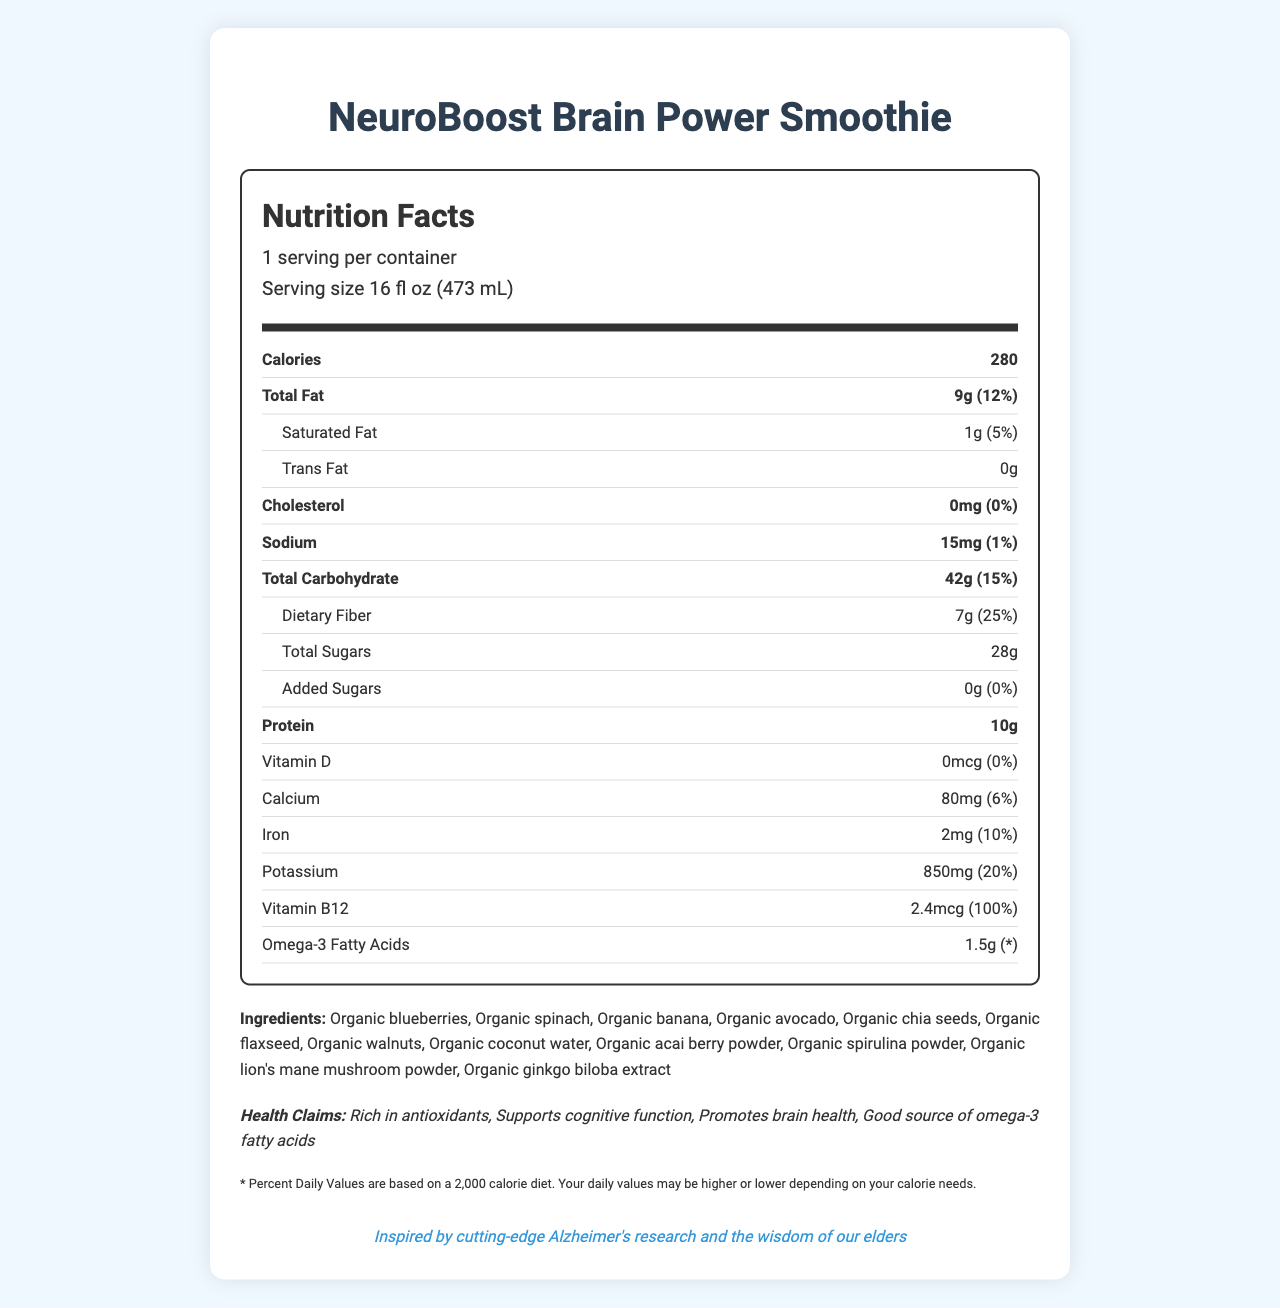what is the serving size? The serving size is stated as "16 fl oz (473 mL)" in the document.
Answer: 16 fl oz (473 mL) how many calories are in one serving? The number of calories per serving is indicated as "280" in the document.
Answer: 280 what is the total amount of dietary fiber per serving? The amount of dietary fiber per serving is given as "7g" in the document.
Answer: 7g what percentage of the daily value is the total fat per serving? The total fat percentage of the daily value per serving is listed as "12%" in the document.
Answer: 12% what is the main health claim of the product? Among the listed health claims, "Supports cognitive function" stands out as a primary claim related to brain health.
Answer: Supports cognitive function which ingredient is an allergen? A. Organic chia seeds B. Organic walnuts C. Organic avocado D. Organic spinach The allergen information indicates that the product contains tree nuts, specifically "walnuts."
Answer: B how much protein does one serving contain? The amount of protein per serving is "10g" as stated in the document.
Answer: 10g does this product contain any trans fat? The document specifies "Trans Fat 0g," indicating there is no trans fat in the product.
Answer: No what is the manufacturer location of the product? The manufacturer is "BrainFuel Nutrition Labs, Los Angeles, CA 90001" as noted in the document.
Answer: Los Angeles, CA 90001 what percentage of the daily value of vitamin B12 is in the smoothie? The document indicates that vitamin B12 is present at 2.4mcg, which is 100% of the daily value.
Answer: 100% if one were to consume two servings, how much vitamin D would they intake? The document states that the amount of vitamin D per serving is "0mcg," so consuming two servings would still result in "0mcg" intake.
Answer: 0mcg which claim is not listed in the health claims section? A. Rich in antioxidants B. Supports cognitive function C. Boosts immunity D. Promotes brain health The health claims listed are "Rich in antioxidants," "Supports cognitive function," and "Promotes brain health." "Boosts immunity" is not mentioned.
Answer: C how much added sugars does the product contain per serving? The document mentions that the added sugars per serving amount to "0g."
Answer: 0g is this product suitable for people with walnut allergies? The allergen information clearly states that the product contains tree nuts (walnuts), making it unsuitable for someone with a walnut allergy.
Answer: No summarize the main idea of the document The document serves to provide detailed nutritional information and emphasize the cognitive and brain health benefits of the NeuroBoost Brain Power Smoothie, listing its features, ingredients, and manufacturer information.
Answer: The NeuroBoost Brain Power Smoothie is a nutrient-packed beverage designed to promote brain health, with key ingredients and vitamins that support cognitive function and rich in antioxidants. The product provides detailed nutritional information, including calories, fats, proteins, carbohydrates, and essential vitamins. It emphasizes brain-boosting ingredients and provides allergen information, health claims, and storage guidelines. how many different organic ingredients are listed? The document lists the following organic ingredients: "Organic blueberries, Organic spinach, Organic banana, Organic avocado, Organic chia seeds, Organic flaxseed, Organic walnuts, Organic coconut water, Organic acai berry powder, Organic spirulina powder, Organic lion's mane mushroom powder, Organic ginkgo biloba extract," totaling 12.
Answer: 12 what are the total sugars per serving, and how do they compare to the added sugars in the document? The document differentiates between "Total Sugars 28g" and "Added Sugars 0g," indicating that all sugars come from natural sources within the ingredients.
Answer: 28g total sugars, 0g added sugars how much calcium does one serving contain? The document indicates that the calcium content per serving is "80mg."
Answer: 80mg what is the omega-3 fatty acids daily value percentage? The document specifies "Omega-3 Fatty Acids 1.5g" but does not provide a percentage daily value, marked with an asterisk indicating more information is needed.
Answer: Unknown / Not provided 